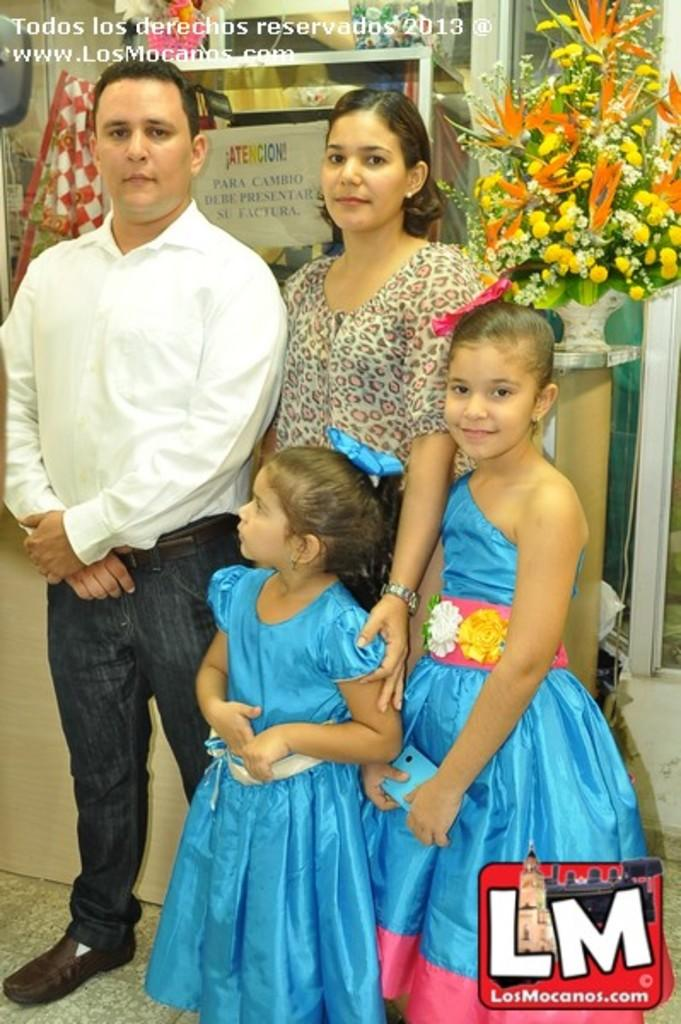What can be seen in the image involving people? There are people standing in the image. What is located near the people in the image? There is a flower vase in the image. What is visible behind the people in the image? There are objects behind the people in the image. What is written or displayed at the top of the image? There is text at the top of the image. What is present in the bottom right corner of the image? There is a logo in the bottom right corner of the image. What type of glass can be seen on the foot of the person in the image? There is no glass or foot visible in the image; it only shows people standing, a flower vase, objects behind them, text at the top, and a logo in the bottom right corner. 